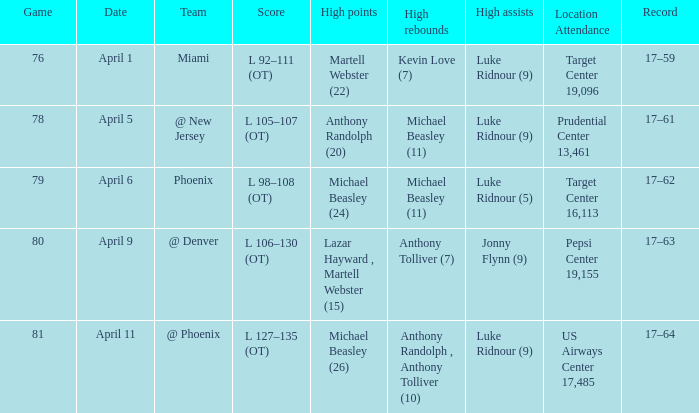Who did the most high rebounds on April 6? Michael Beasley (11). 